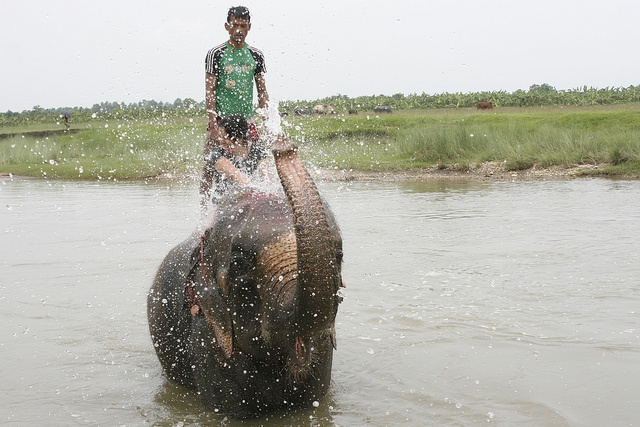Describe the objects in this image and their specific colors. I can see elephant in white, black, gray, and darkgray tones, people in white, gray, darkgray, lightgray, and teal tones, people in white, lightgray, darkgray, gray, and black tones, and people in white, gray, and black tones in this image. 